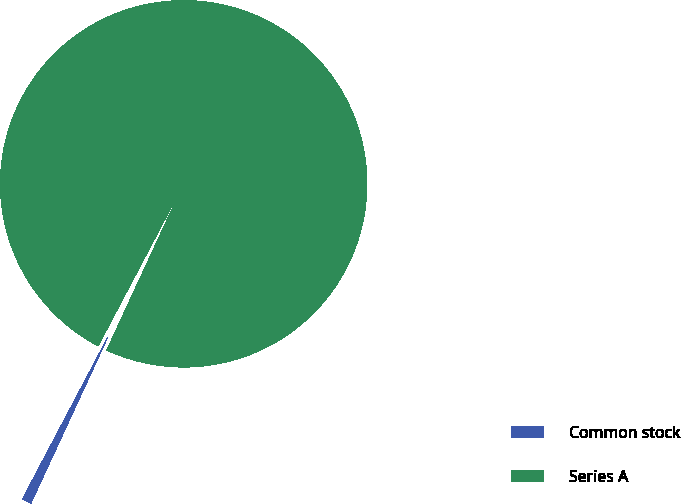Convert chart. <chart><loc_0><loc_0><loc_500><loc_500><pie_chart><fcel>Common stock<fcel>Series A<nl><fcel>0.83%<fcel>99.17%<nl></chart> 